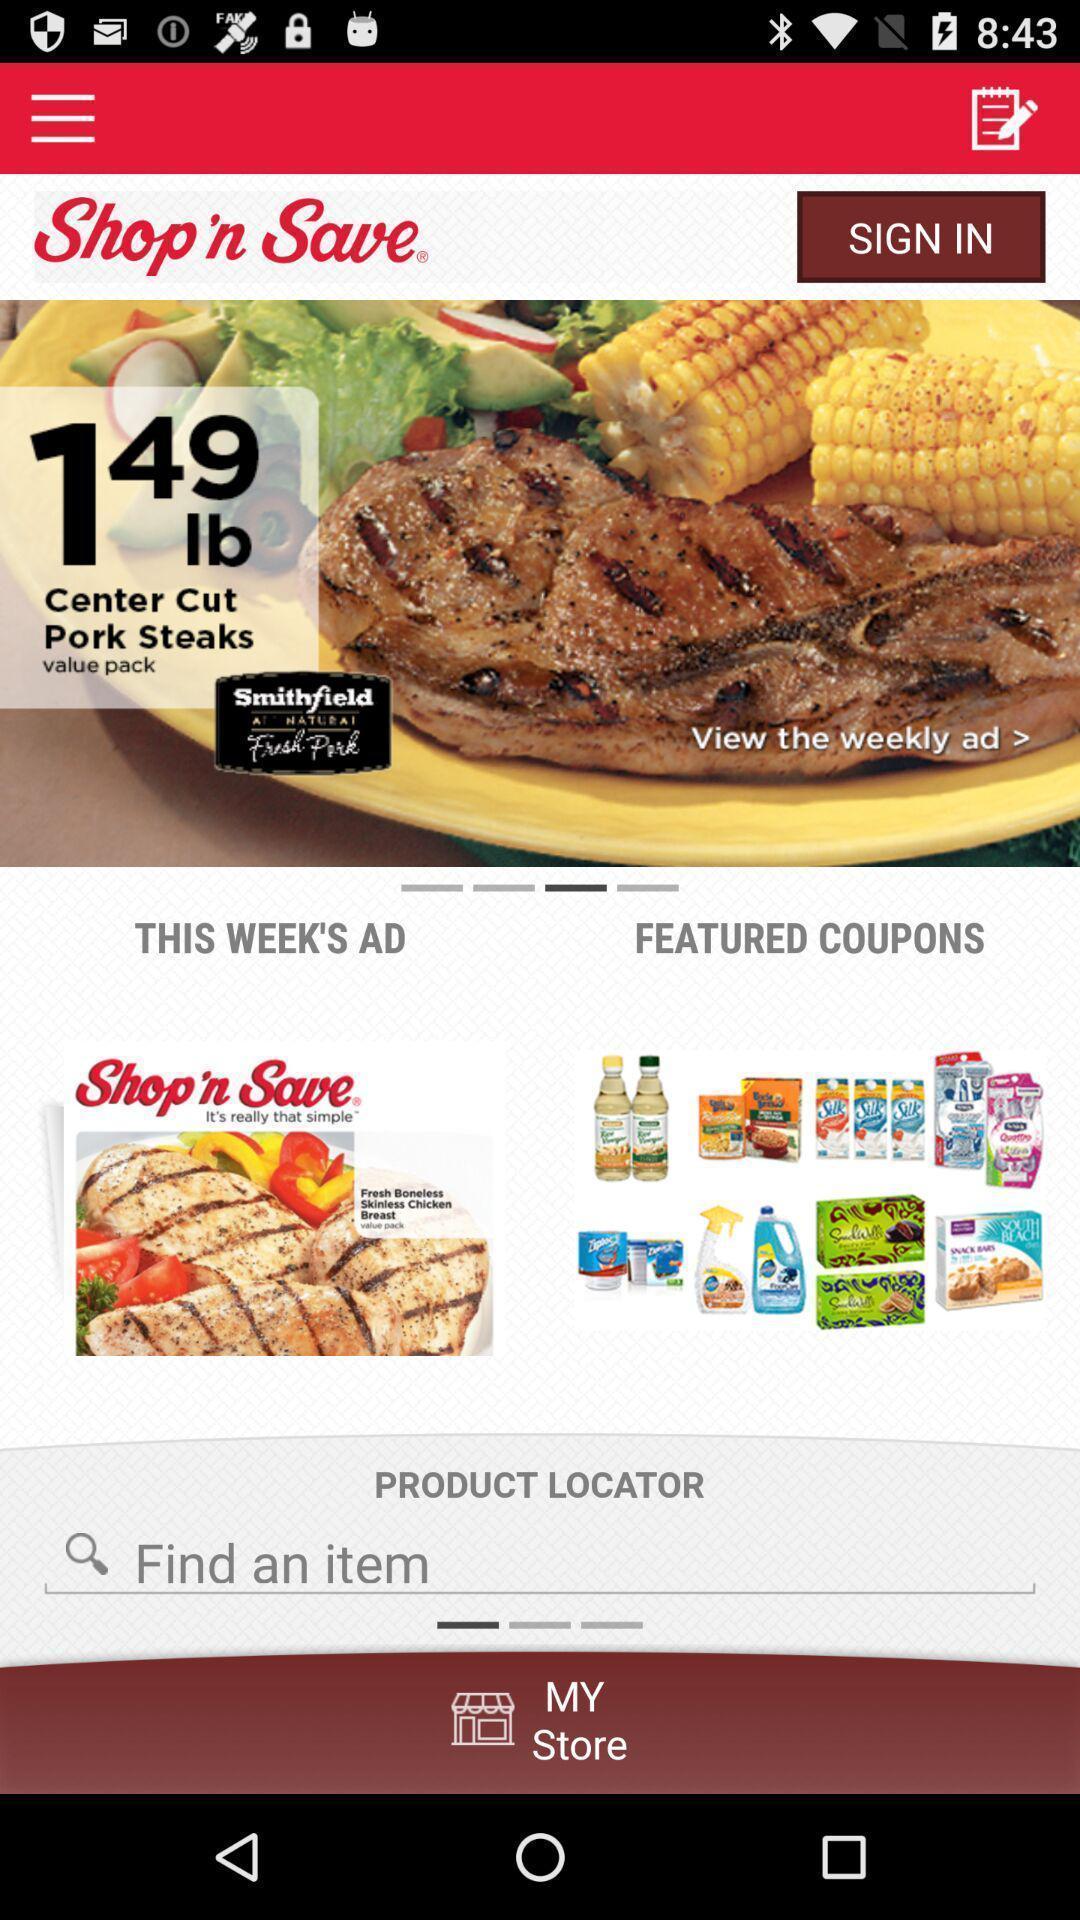Summarize the information in this screenshot. Sign-in page of a shopping app. 